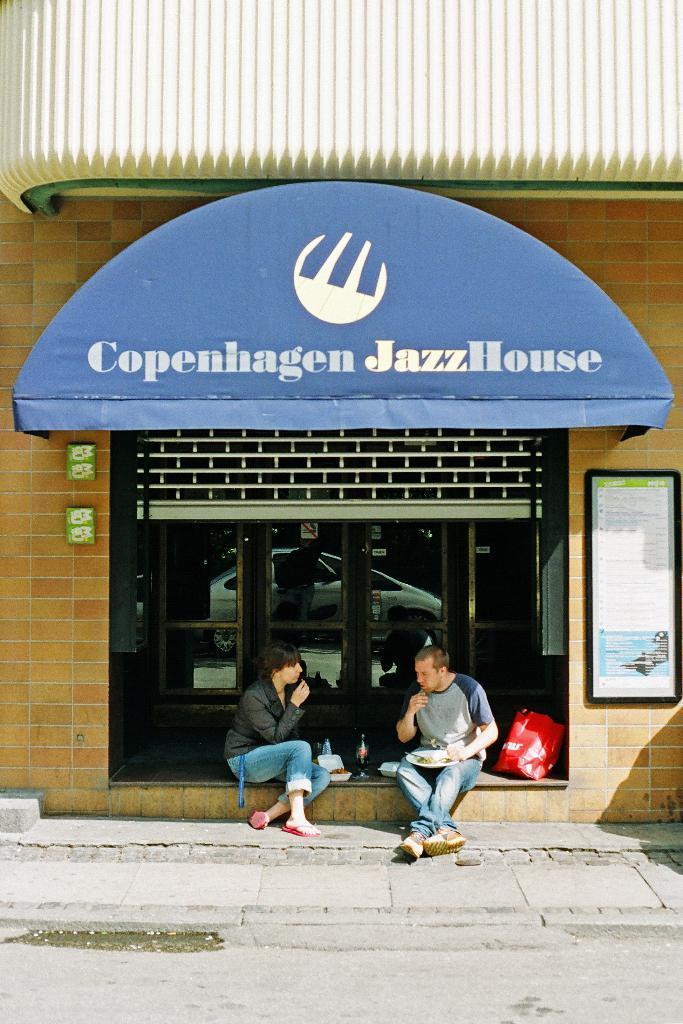Could you give a brief overview of what you see in this image? There are two persons sitting in front of a store and there are eatables in front of them. 